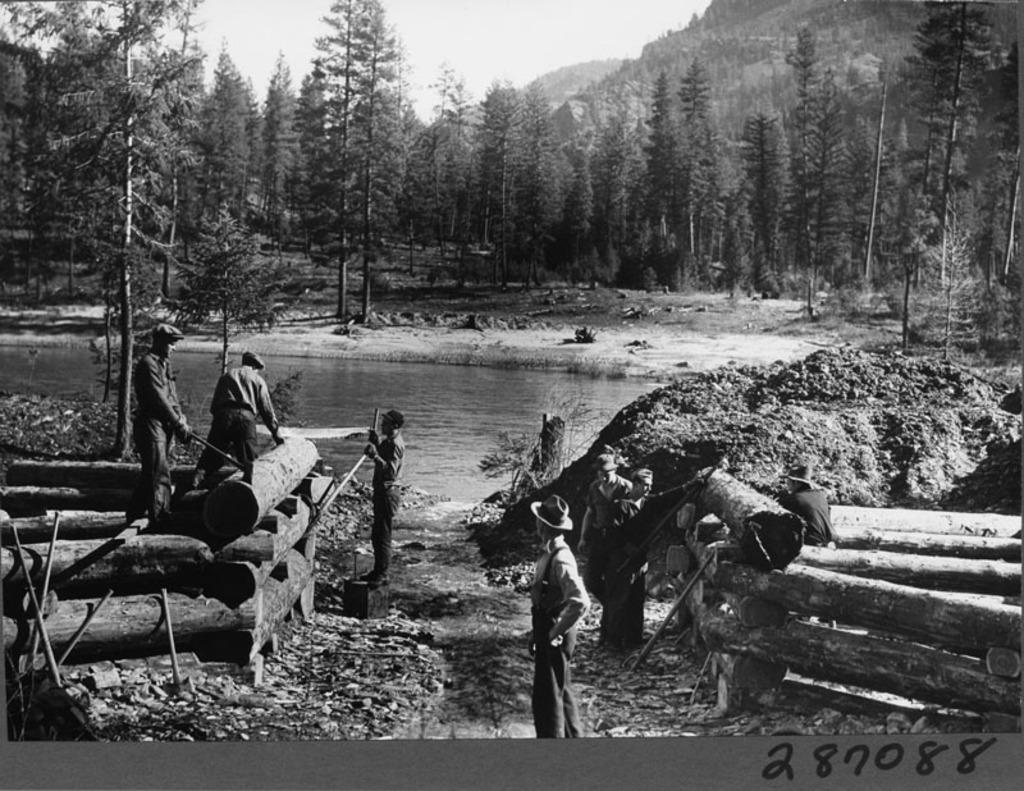How would you summarize this image in a sentence or two? In this black and white picture few persons are standing on the land. Left side few persons are standing on the wooden trunks. There are few wooden trunks on the land. Middle of the image there is water. There are few trees on the land. Behind there are hills. Top of the image there is sky. 